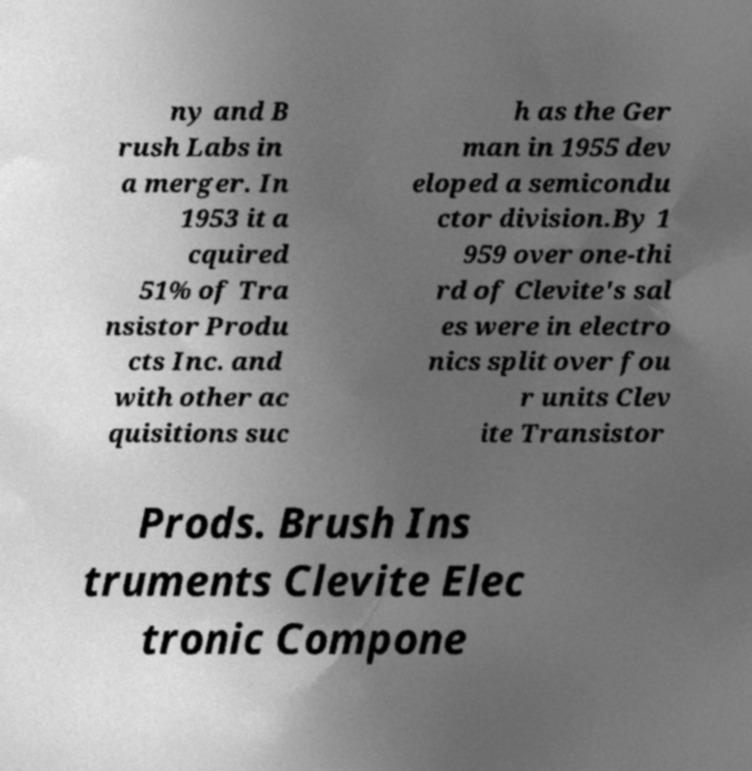What messages or text are displayed in this image? I need them in a readable, typed format. ny and B rush Labs in a merger. In 1953 it a cquired 51% of Tra nsistor Produ cts Inc. and with other ac quisitions suc h as the Ger man in 1955 dev eloped a semicondu ctor division.By 1 959 over one-thi rd of Clevite's sal es were in electro nics split over fou r units Clev ite Transistor Prods. Brush Ins truments Clevite Elec tronic Compone 